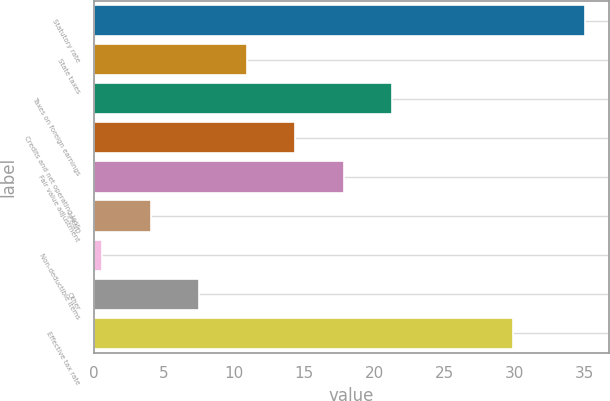Convert chart to OTSL. <chart><loc_0><loc_0><loc_500><loc_500><bar_chart><fcel>Statutory rate<fcel>State taxes<fcel>Taxes on foreign earnings<fcel>Credits and net operating loss<fcel>Fair value adjustment<fcel>IPR&D<fcel>Non-deductible items<fcel>Other<fcel>Effective tax rate<nl><fcel>35<fcel>10.92<fcel>21.24<fcel>14.36<fcel>17.8<fcel>4.04<fcel>0.6<fcel>7.48<fcel>29.9<nl></chart> 